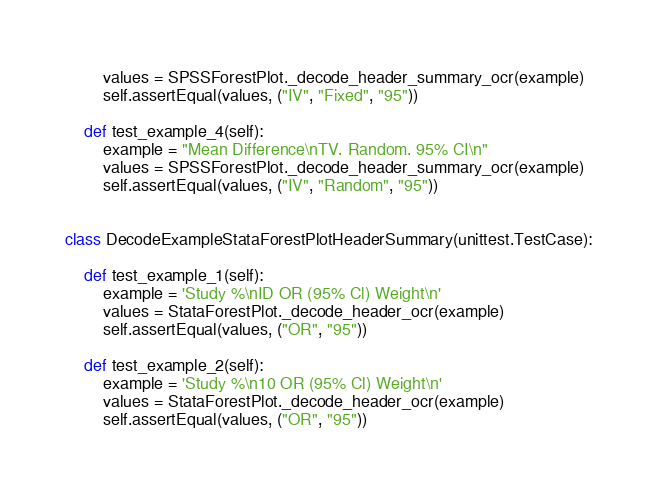Convert code to text. <code><loc_0><loc_0><loc_500><loc_500><_Python_>        values = SPSSForestPlot._decode_header_summary_ocr(example)
        self.assertEqual(values, ("IV", "Fixed", "95"))

    def test_example_4(self):
        example = "Mean Difference\nTV. Random. 95% CI\n"
        values = SPSSForestPlot._decode_header_summary_ocr(example)
        self.assertEqual(values, ("IV", "Random", "95"))


class DecodeExampleStataForestPlotHeaderSummary(unittest.TestCase):

    def test_example_1(self):
        example = 'Study %\nID OR (95% Cl) Weight\n'
        values = StataForestPlot._decode_header_ocr(example)
        self.assertEqual(values, ("OR", "95"))

    def test_example_2(self):
        example = 'Study %\n10 OR (95% Cl) Weight\n'
        values = StataForestPlot._decode_header_ocr(example)
        self.assertEqual(values, ("OR", "95"))
</code> 